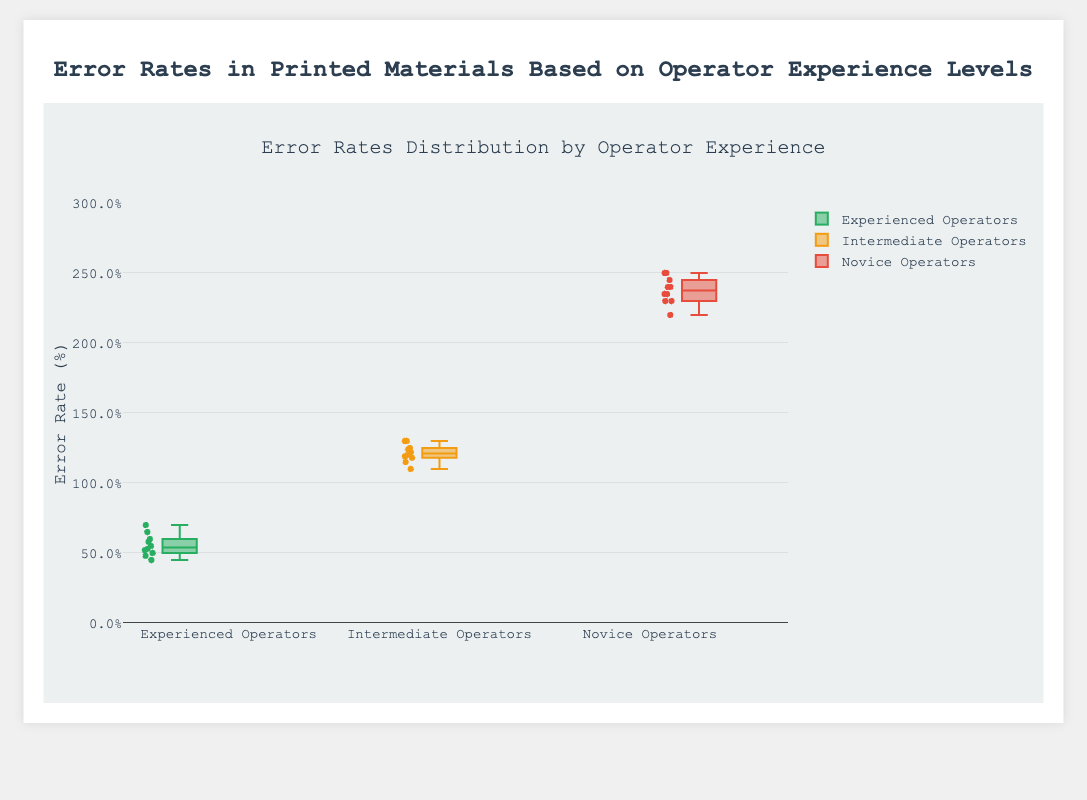What is the title of the figure? The title is located at the top of the figure. It provides an overall description of what the plot is about.
Answer: Error Rates in Printed Materials Based on Operator Experience Levels What is the range of the y-axis? The range of the y-axis can be identified by looking at the scale provided next to it. The lower bound is at 0 and the upper bound is at 3, according to the provided range.
Answer: 0 to 3 Which operator experience level group shows the lowest error rate? To find the group with the lowest error rate, compare the minimum values of the box plots for all three groups. The lowest point is under Experienced Operators.
Answer: Experienced Operators What is the difference between the median error rates of Intermediate Operators and Novice Operators? First, identify the median lines in the center of the boxes for both Intermediate and Novice Operators. Calculate the difference between these two median values.
Answer: Approximately 1.1 - 2.35 = -1.25 How many data points are displayed for Novice Operators? Count the individual points plotted within the box plot for Novice Operators. Each point represents an error rate from the dataset.
Answer: 10 Which group has the highest interquartile range (IQR)? The IQR is the range between the first and third quartiles in the box plot. Compare the heights of the boxes across the groups. The Novice Operators box appears to have the largest IQR.
Answer: Novice Operators What is the median error rate for Experienced Operators? Locate the median line inside the box for Experienced Operators. The value where this line intersects the y-axis is the median error rate.
Answer: Approximately 0.55 Which company has the highest error rate among Experienced Operators? Look at the individual points plotted within the Experienced Operators box plot. The highest point represents the company with the highest error rate. GlobalPrint has the highest point among Experienced Operators.
Answer: GlobalPrint How do the error rates of Intermediate Operators compare to Experienced Operators in general? Compare the general spread of the error rates by examining the quartile ranges, medians, and outliers. Intermediate Operators have higher median and spread of error rates compared to Experienced Operators.
Answer: Intermediate Operators have higher error rates What is the color used for the Novice Operators' box plot? Identify the color representing the Novice Operators by looking at the color coding in the legend. The Novice Operators' box plot is colored red.
Answer: Red 